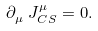<formula> <loc_0><loc_0><loc_500><loc_500>\partial ^ { \ } _ { \mu } J ^ { \mu } _ { C S } = 0 .</formula> 